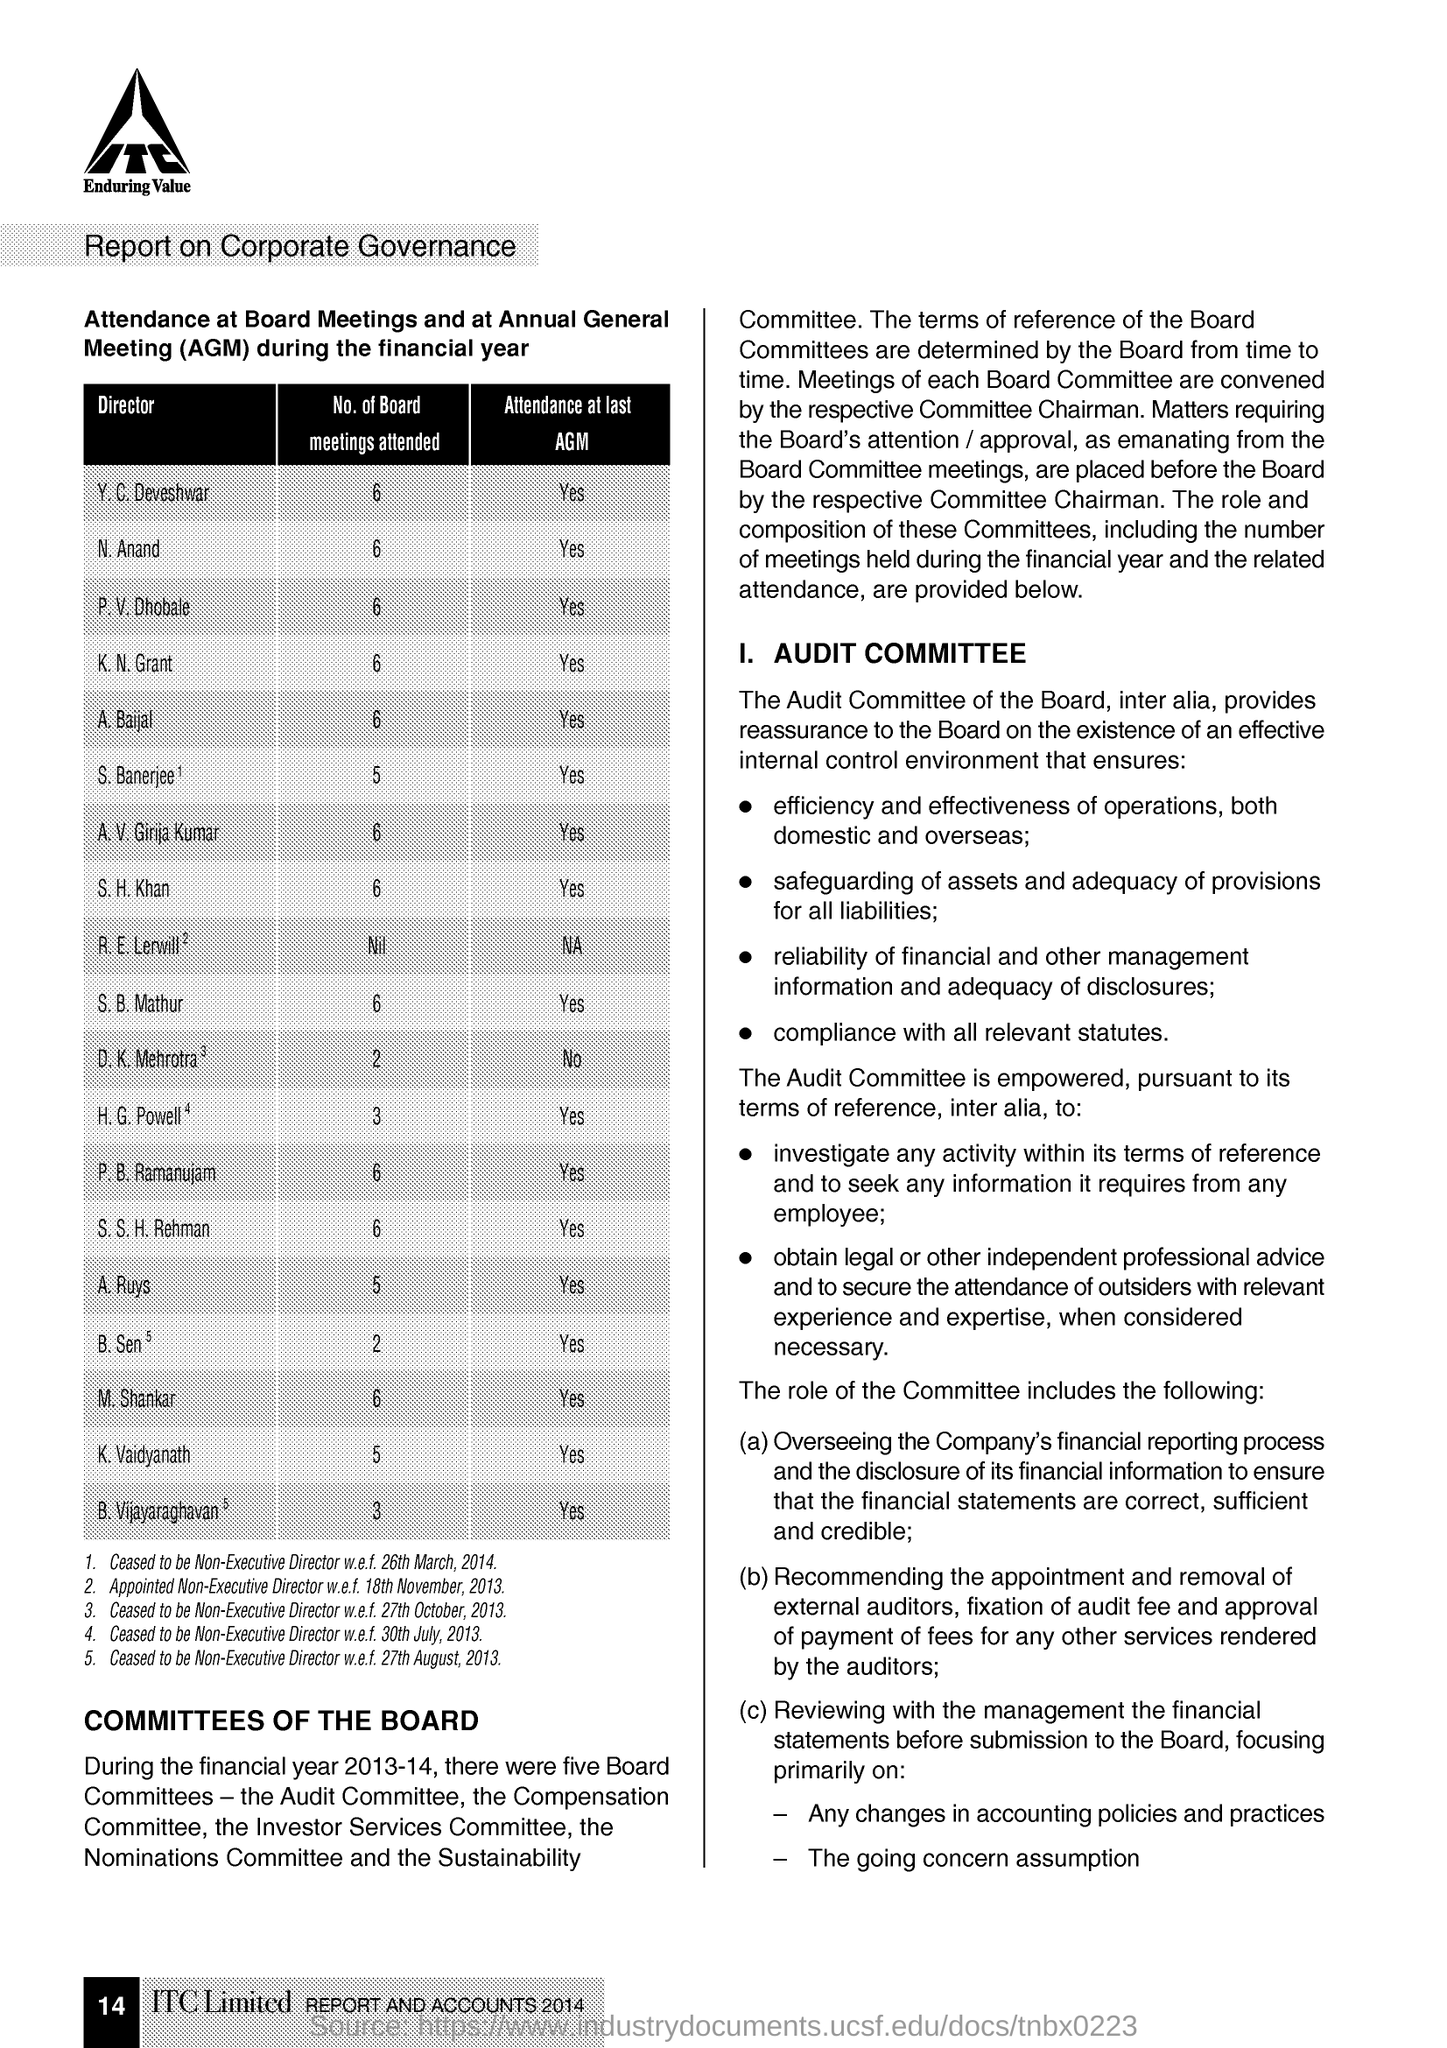Give some essential details in this illustration. AGM stands for Annual General Meeting. Anand, N attended 6 Board meetings. 